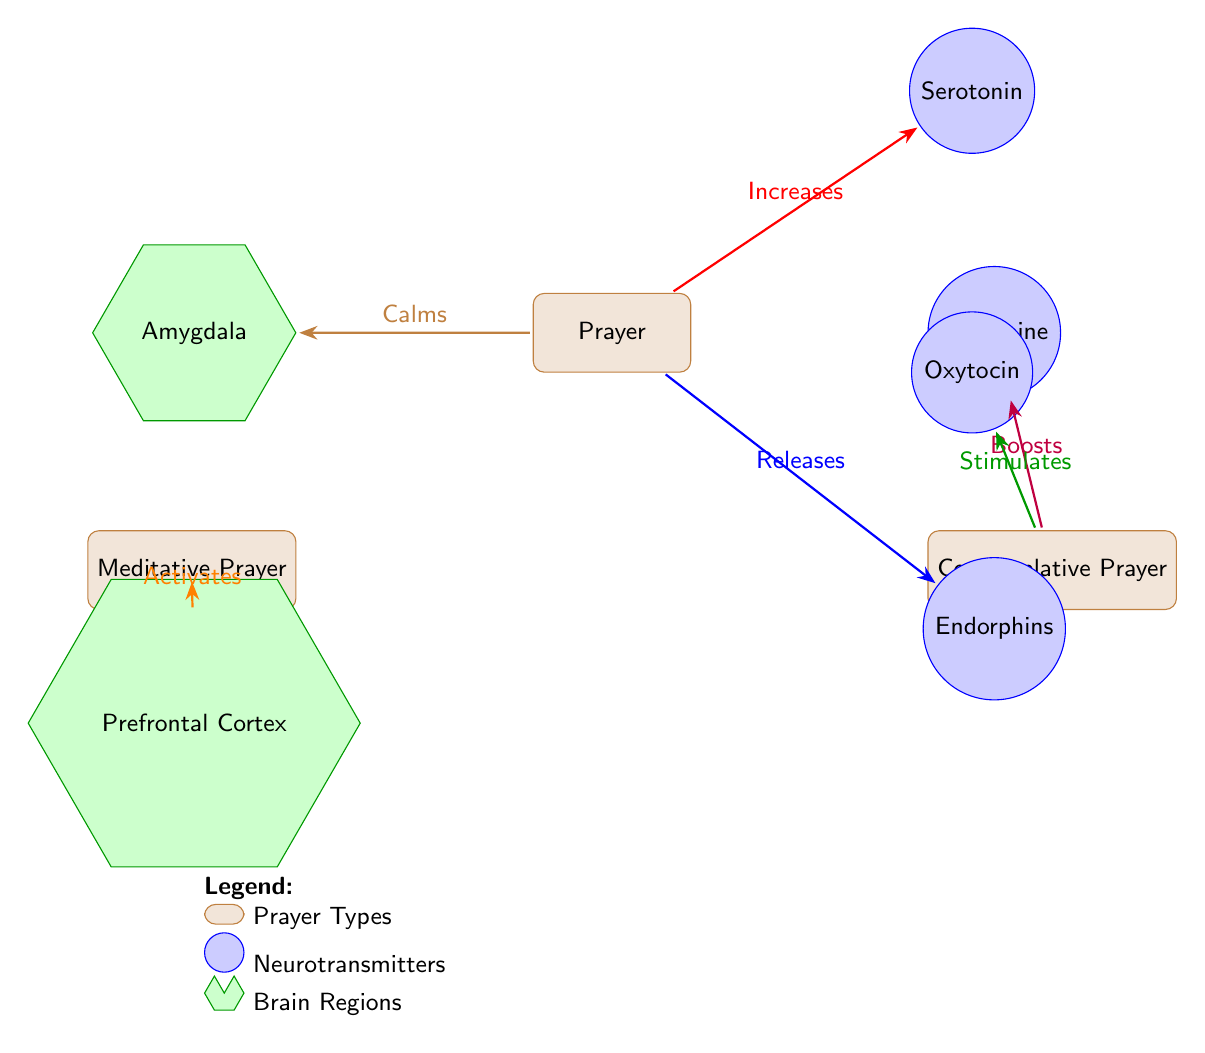What are the two types of prayer shown in the diagram? The diagram includes two types of prayer which are Meditative Prayer and Contemplative Prayer, located below the main Prayer node and leading to different neurotransmitters.
Answer: Meditative Prayer and Contemplative Prayer Which neurotransmitter is increased by prayer? The Prayer node has an arrow pointing to the Serotonin node with the label "Increases," indicating that prayer increases serotonin levels.
Answer: Serotonin How does contemplative prayer affect dopamine? The Contemplative Prayer node has an arrow pointing to the Dopamine node labeled "Boosts," indicating that contemplative prayer boosts dopamine levels.
Answer: Boosts What brain region is calmed by prayer? An arrow from the Prayer node to the Amygdala is labeled "Calms," indicating that prayer calms the Amygdala region of the brain.
Answer: Amygdala How many types of neurotransmitters are represented in the diagram? There are four neurotransmitter nodes: Serotonin, Dopamine, Endorphins, and Oxytocin, indicating that four types of neurotransmitters are represented in the diagram.
Answer: Four Which type of prayer activates the prefrontal cortex? The diagram shows an arrow from the Meditative Prayer node to the Prefrontal Cortex node labeled "Activates," indicating that meditative prayer activates this brain region.
Answer: Meditative Prayer What is the relationship between contemplative prayer and oxytocin? The diagram indicates that Contemplative Prayer "Stimulates" the Oxytocin node, showing a direct relationship where this type of prayer stimulates oxytocin release.
Answer: Stimulates Which neurotransmitter is released by prayer? The diagram includes an arrow from the Prayer node to the Endorphins node labeled "Releases," meaning that prayer results in the release of endorphins.
Answer: Releases What are the three effects of prayer on neurochemical functioning? The effects are: Increases serotonin, Releases endorphins, and Calms the amygdala, as shown by the various arrows leading from the Prayer node to the respective neurotransmitter nodes and brain regions.
Answer: Increases serotonin, Releases endorphins, Calms the amygdala 